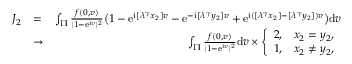Convert formula to latex. <formula><loc_0><loc_0><loc_500><loc_500>\begin{array} { r l r } { J _ { 2 } } & { = } & { \int _ { \Pi } \frac { f ( 0 , v ) } { | 1 - \mathrm e ^ { \mathrm i v } | ^ { 2 } } \left ( 1 - \mathrm e ^ { \mathrm i [ \lambda ^ { \gamma } x _ { 2 } ] v } - \mathrm e ^ { - \mathrm i [ \lambda ^ { \gamma } y _ { 2 } ] v } + \mathrm e ^ { \mathrm i ( [ \lambda ^ { \gamma } x _ { 2 } ] - [ \lambda ^ { \gamma } y _ { 2 } ] ) v } \right ) \mathrm d v } \\ & { \to } & { \int _ { \Pi } \frac { f ( 0 , v ) } { | 1 - \mathrm e ^ { \mathrm i v } | ^ { 2 } } \mathrm d v \times \left \{ \begin{array} { l l } { 2 , } & { x _ { 2 } = y _ { 2 } , } \\ { 1 , } & { x _ { 2 } \ne y _ { 2 } , } \end{array} } \end{array}</formula> 